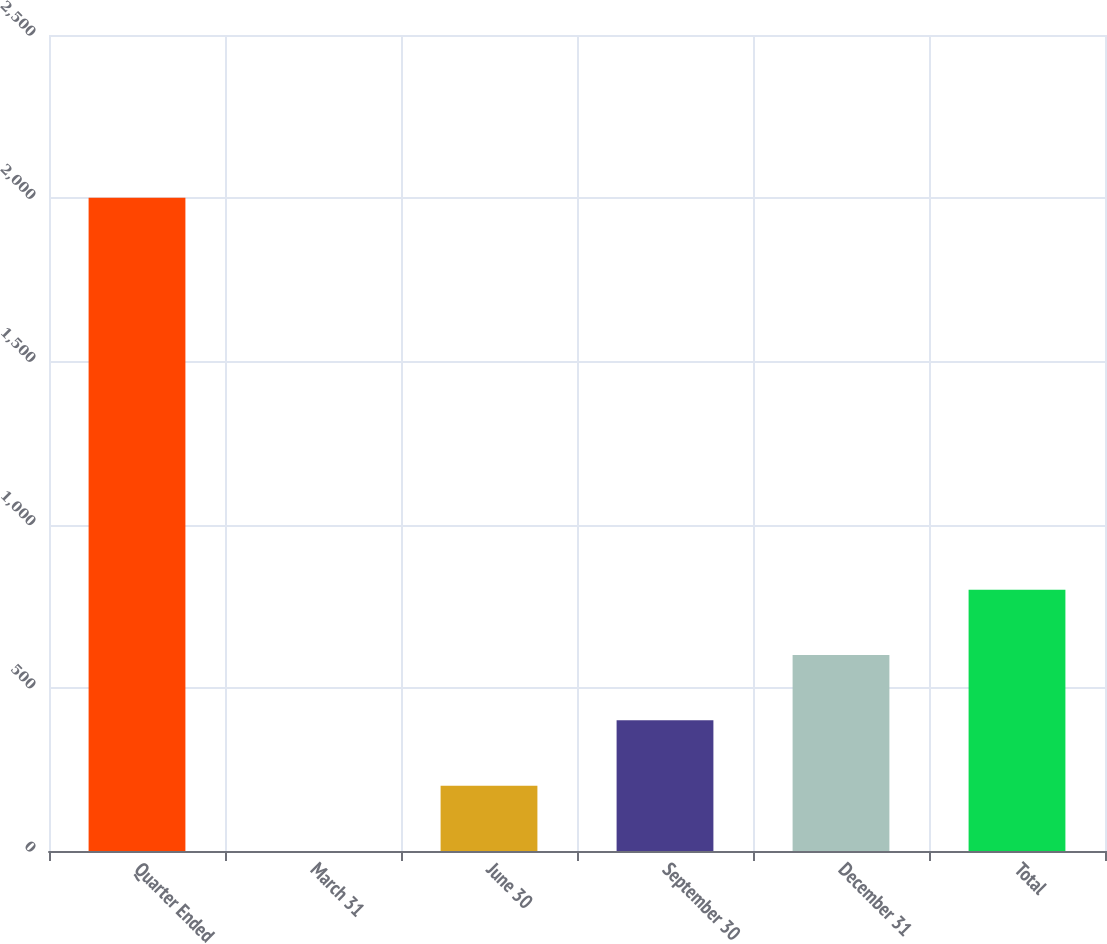<chart> <loc_0><loc_0><loc_500><loc_500><bar_chart><fcel>Quarter Ended<fcel>March 31<fcel>June 30<fcel>September 30<fcel>December 31<fcel>Total<nl><fcel>2001<fcel>0.16<fcel>200.24<fcel>400.32<fcel>600.4<fcel>800.48<nl></chart> 